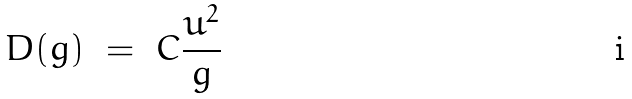<formula> <loc_0><loc_0><loc_500><loc_500>D ( g ) \ = \ C \frac { u ^ { 2 } } { g }</formula> 